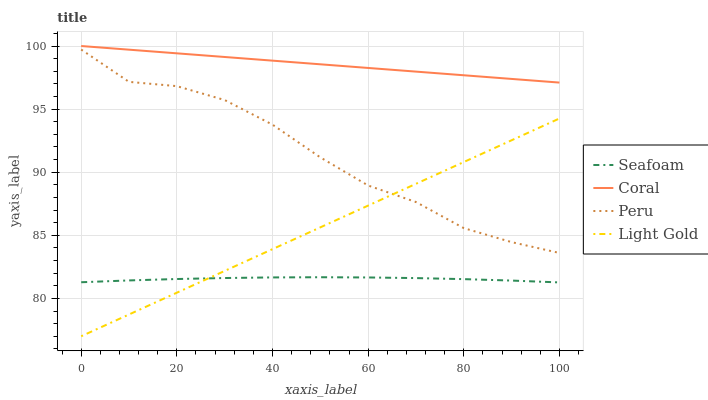Does Seafoam have the minimum area under the curve?
Answer yes or no. Yes. Does Coral have the maximum area under the curve?
Answer yes or no. Yes. Does Light Gold have the minimum area under the curve?
Answer yes or no. No. Does Light Gold have the maximum area under the curve?
Answer yes or no. No. Is Coral the smoothest?
Answer yes or no. Yes. Is Peru the roughest?
Answer yes or no. Yes. Is Light Gold the smoothest?
Answer yes or no. No. Is Light Gold the roughest?
Answer yes or no. No. Does Light Gold have the lowest value?
Answer yes or no. Yes. Does Seafoam have the lowest value?
Answer yes or no. No. Does Coral have the highest value?
Answer yes or no. Yes. Does Light Gold have the highest value?
Answer yes or no. No. Is Light Gold less than Coral?
Answer yes or no. Yes. Is Peru greater than Seafoam?
Answer yes or no. Yes. Does Light Gold intersect Peru?
Answer yes or no. Yes. Is Light Gold less than Peru?
Answer yes or no. No. Is Light Gold greater than Peru?
Answer yes or no. No. Does Light Gold intersect Coral?
Answer yes or no. No. 